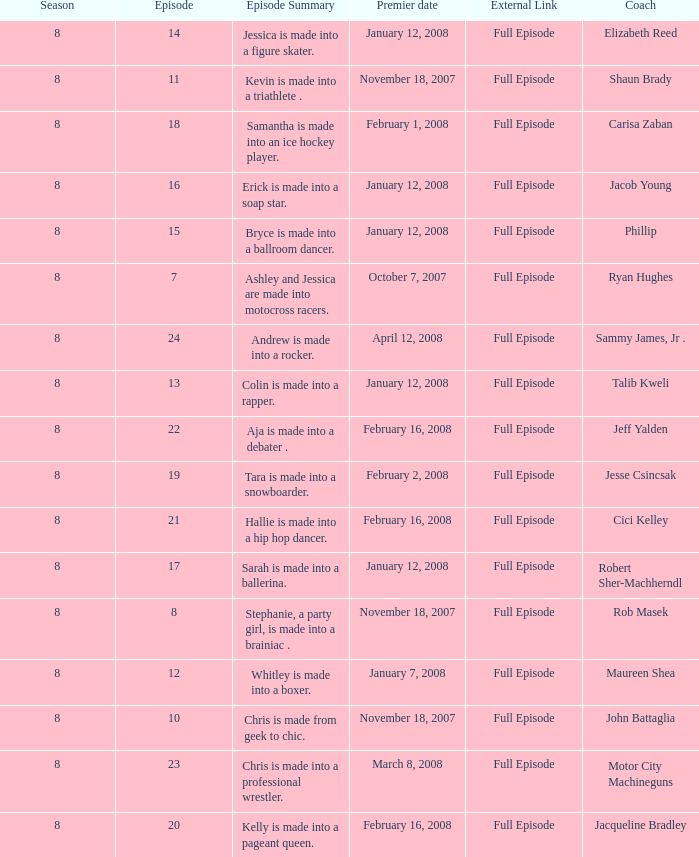Which Maximum episode premiered March 8, 2008? 23.0. I'm looking to parse the entire table for insights. Could you assist me with that? {'header': ['Season', 'Episode', 'Episode Summary', 'Premier date', 'External Link', 'Coach'], 'rows': [['8', '14', 'Jessica is made into a figure skater.', 'January 12, 2008', 'Full Episode', 'Elizabeth Reed'], ['8', '11', 'Kevin is made into a triathlete .', 'November 18, 2007', 'Full Episode', 'Shaun Brady'], ['8', '18', 'Samantha is made into an ice hockey player.', 'February 1, 2008', 'Full Episode', 'Carisa Zaban'], ['8', '16', 'Erick is made into a soap star.', 'January 12, 2008', 'Full Episode', 'Jacob Young'], ['8', '15', 'Bryce is made into a ballroom dancer.', 'January 12, 2008', 'Full Episode', 'Phillip'], ['8', '7', 'Ashley and Jessica are made into motocross racers.', 'October 7, 2007', 'Full Episode', 'Ryan Hughes'], ['8', '24', 'Andrew is made into a rocker.', 'April 12, 2008', 'Full Episode', 'Sammy James, Jr .'], ['8', '13', 'Colin is made into a rapper.', 'January 12, 2008', 'Full Episode', 'Talib Kweli'], ['8', '22', 'Aja is made into a debater .', 'February 16, 2008', 'Full Episode', 'Jeff Yalden'], ['8', '19', 'Tara is made into a snowboarder.', 'February 2, 2008', 'Full Episode', 'Jesse Csincsak'], ['8', '21', 'Hallie is made into a hip hop dancer.', 'February 16, 2008', 'Full Episode', 'Cici Kelley'], ['8', '17', 'Sarah is made into a ballerina.', 'January 12, 2008', 'Full Episode', 'Robert Sher-Machherndl'], ['8', '8', 'Stephanie, a party girl, is made into a brainiac .', 'November 18, 2007', 'Full Episode', 'Rob Masek'], ['8', '12', 'Whitley is made into a boxer.', 'January 7, 2008', 'Full Episode', 'Maureen Shea'], ['8', '10', 'Chris is made from geek to chic.', 'November 18, 2007', 'Full Episode', 'John Battaglia'], ['8', '23', 'Chris is made into a professional wrestler.', 'March 8, 2008', 'Full Episode', 'Motor City Machineguns'], ['8', '20', 'Kelly is made into a pageant queen.', 'February 16, 2008', 'Full Episode', 'Jacqueline Bradley']]} 